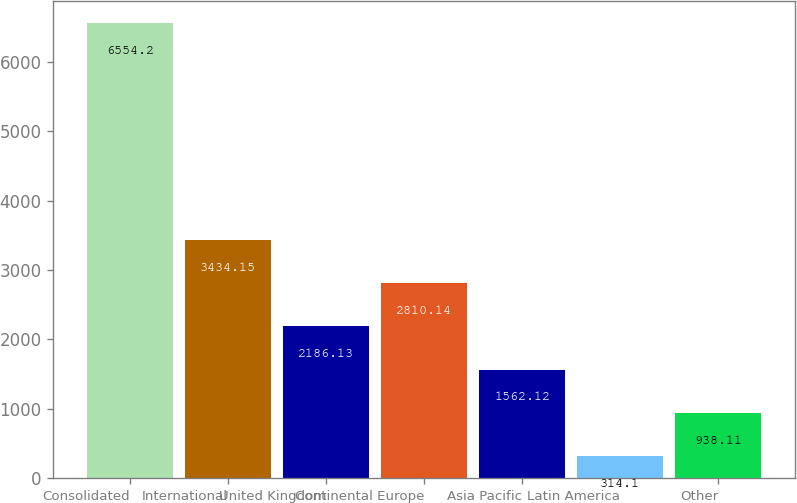Convert chart to OTSL. <chart><loc_0><loc_0><loc_500><loc_500><bar_chart><fcel>Consolidated<fcel>International<fcel>United Kingdom<fcel>Continental Europe<fcel>Asia Pacific<fcel>Latin America<fcel>Other<nl><fcel>6554.2<fcel>3434.15<fcel>2186.13<fcel>2810.14<fcel>1562.12<fcel>314.1<fcel>938.11<nl></chart> 